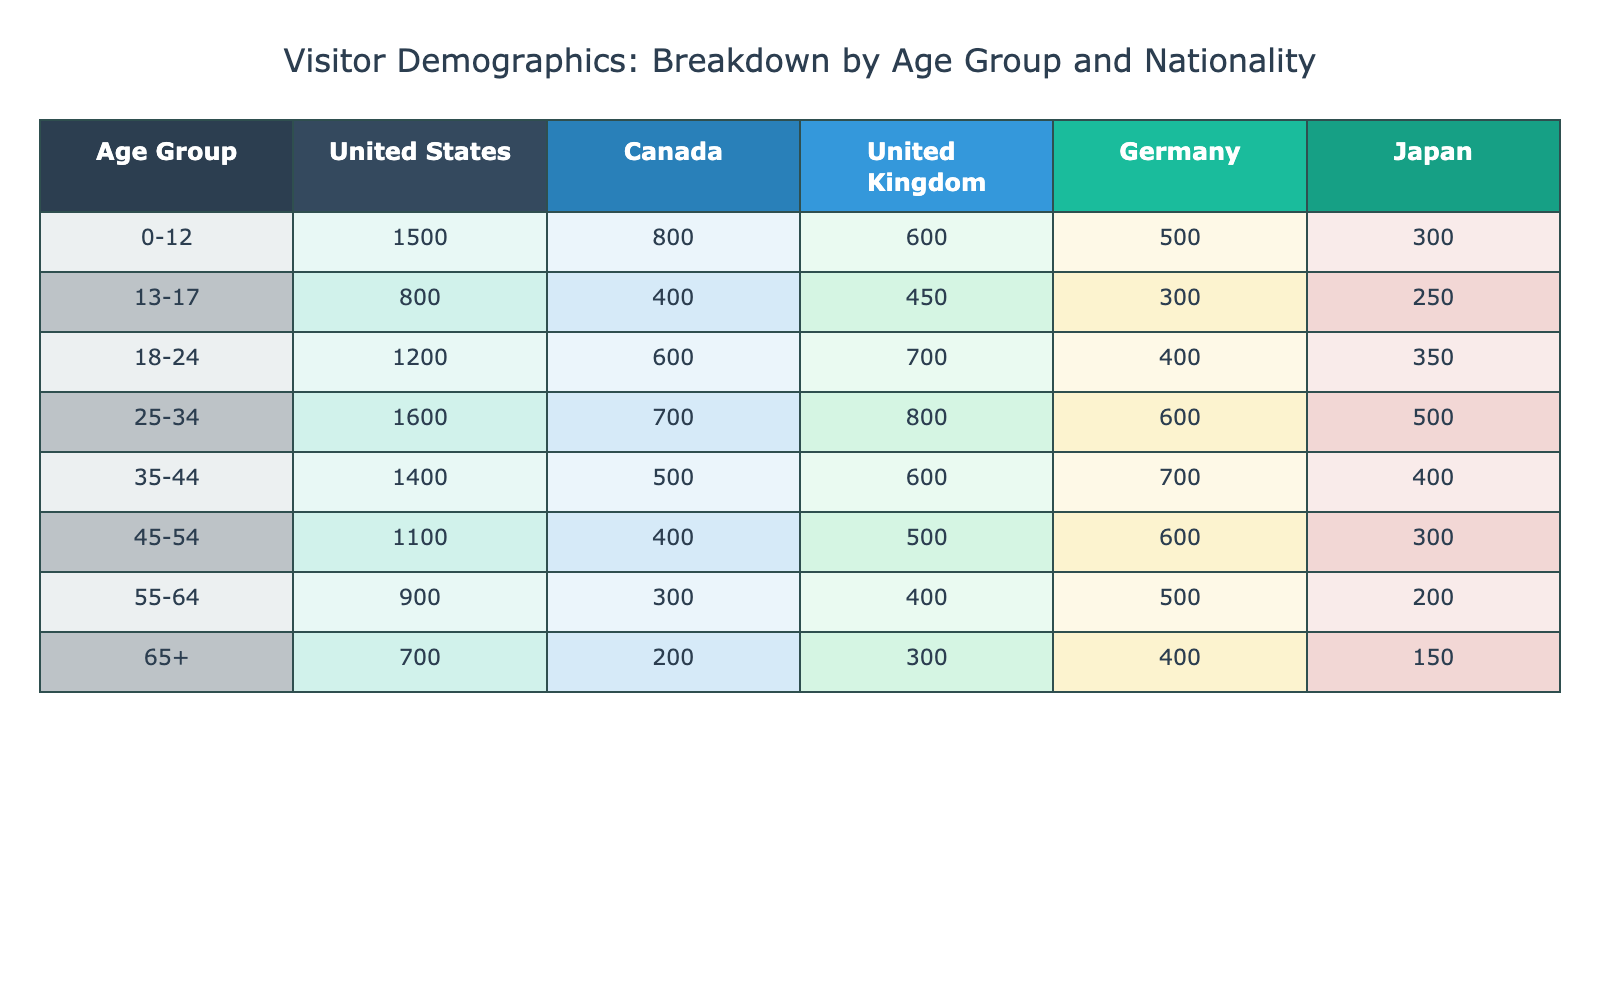What age group has the highest number of visitors from Germany? By examining the column for Germany, the highest number of visitors corresponds to the age group 35-44, which has 700 visitors.
Answer: 35-44 What is the total number of visitors aged 0-12 from all nationalities? To find the total, we add the values for the age group 0-12 across all nationalities: 1500 + 800 + 600 + 500 + 300 = 3700.
Answer: 3700 Is the number of visitors aged 65 and older from the United States greater than those from Canada? The United States has 700 visitors aged 65+, whereas Canada has 200. Since 700 > 200, the statement is true.
Answer: Yes What age group has the lowest total number of visitors across all nationalities? To determine this, we calculate the total for each age group by summing their respective visitors: For 0-12 it's 3700, for 13-17 it's 2200, 18-24 it's 3250, 25-34 it's 4200, 35-44 it's 3200, 45-54 it's 2900, 55-64 it's 2300, and 65+ it's 1750. The lowest total is 1750 for the age group 65+.
Answer: 65+ What is the average number of visitors aged 18-24 from Canada and the United Kingdom combined? First, we find the number of visitors aged 18-24 for Canada (600) and the United Kingdom (700), which gives us a total of 1300. Then we divide by 2 to get the average: 1300 / 2 = 650.
Answer: 650 Which nationality has the lowest total of visitors in the age group 55-64? The values for the age group 55-64 are as follows: United States (900), Canada (300), United Kingdom (400), Germany (500), and Japan (200). The lowest value is from Japan with 200 visitors.
Answer: Japan What is the combined number of visitors aged 25-34 and 35-44 from the United Kingdom? For the United Kingdom, the visitors in the age group 25-34 is 800 and in 35-44 is 600. Adding these two gives us 800 + 600 = 1400.
Answer: 1400 Do more visitors come from the United States than from Japan for the age group 45-54? The United States has 1100 visitors in that age group, while Japan has 300. Since 1100 > 300, the answer is true.
Answer: Yes 